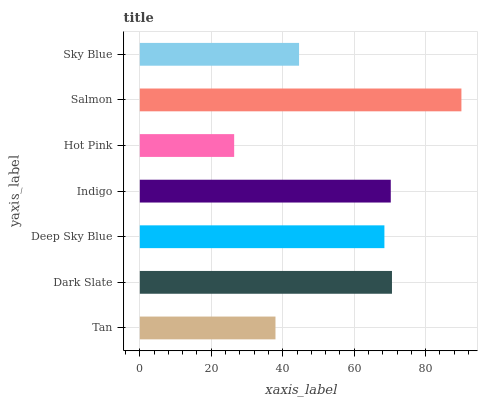Is Hot Pink the minimum?
Answer yes or no. Yes. Is Salmon the maximum?
Answer yes or no. Yes. Is Dark Slate the minimum?
Answer yes or no. No. Is Dark Slate the maximum?
Answer yes or no. No. Is Dark Slate greater than Tan?
Answer yes or no. Yes. Is Tan less than Dark Slate?
Answer yes or no. Yes. Is Tan greater than Dark Slate?
Answer yes or no. No. Is Dark Slate less than Tan?
Answer yes or no. No. Is Deep Sky Blue the high median?
Answer yes or no. Yes. Is Deep Sky Blue the low median?
Answer yes or no. Yes. Is Sky Blue the high median?
Answer yes or no. No. Is Sky Blue the low median?
Answer yes or no. No. 